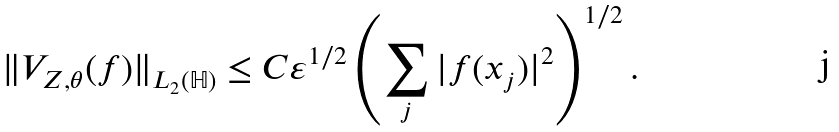Convert formula to latex. <formula><loc_0><loc_0><loc_500><loc_500>\| V _ { Z , \theta } ( f ) \| _ { L _ { 2 } ( \mathbb { H } ) } \leq C \varepsilon ^ { 1 / 2 } \left ( \sum _ { j } | f ( x _ { j } ) | ^ { 2 } \right ) ^ { 1 / 2 } .</formula> 